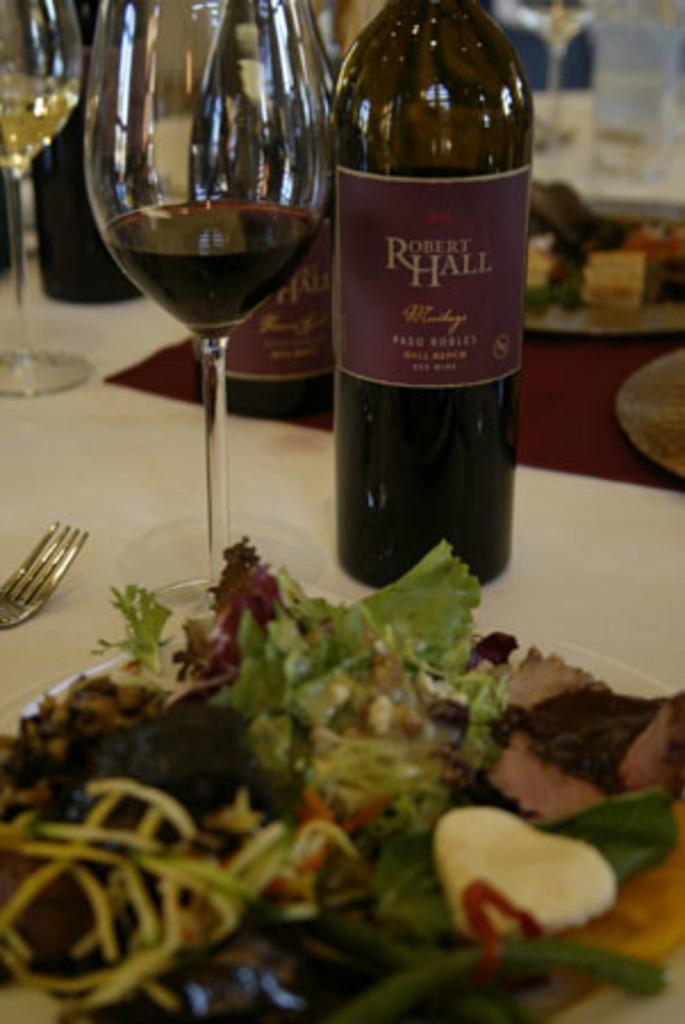Can you describe this image briefly? There is a glass, bottle and a plate full of eatables, fork on the table. The bottle is in brown color. 